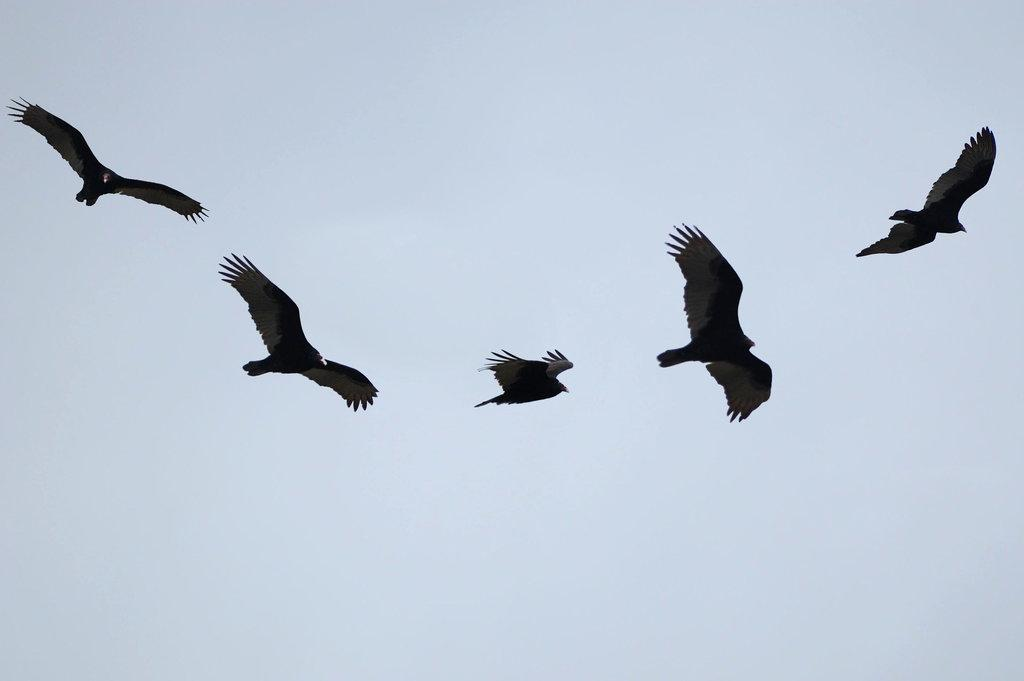What is happening in the sky in the image? There are birds flying in the air. What is the condition of the sky in the image? The sky is cloudy. What type of cart can be seen being smashed by the birds in the image? There is no cart present in the image, and the birds are not smashing anything. How many rings are visible on the birds' beaks in the image? There are no rings visible on the birds' beaks in the image. 